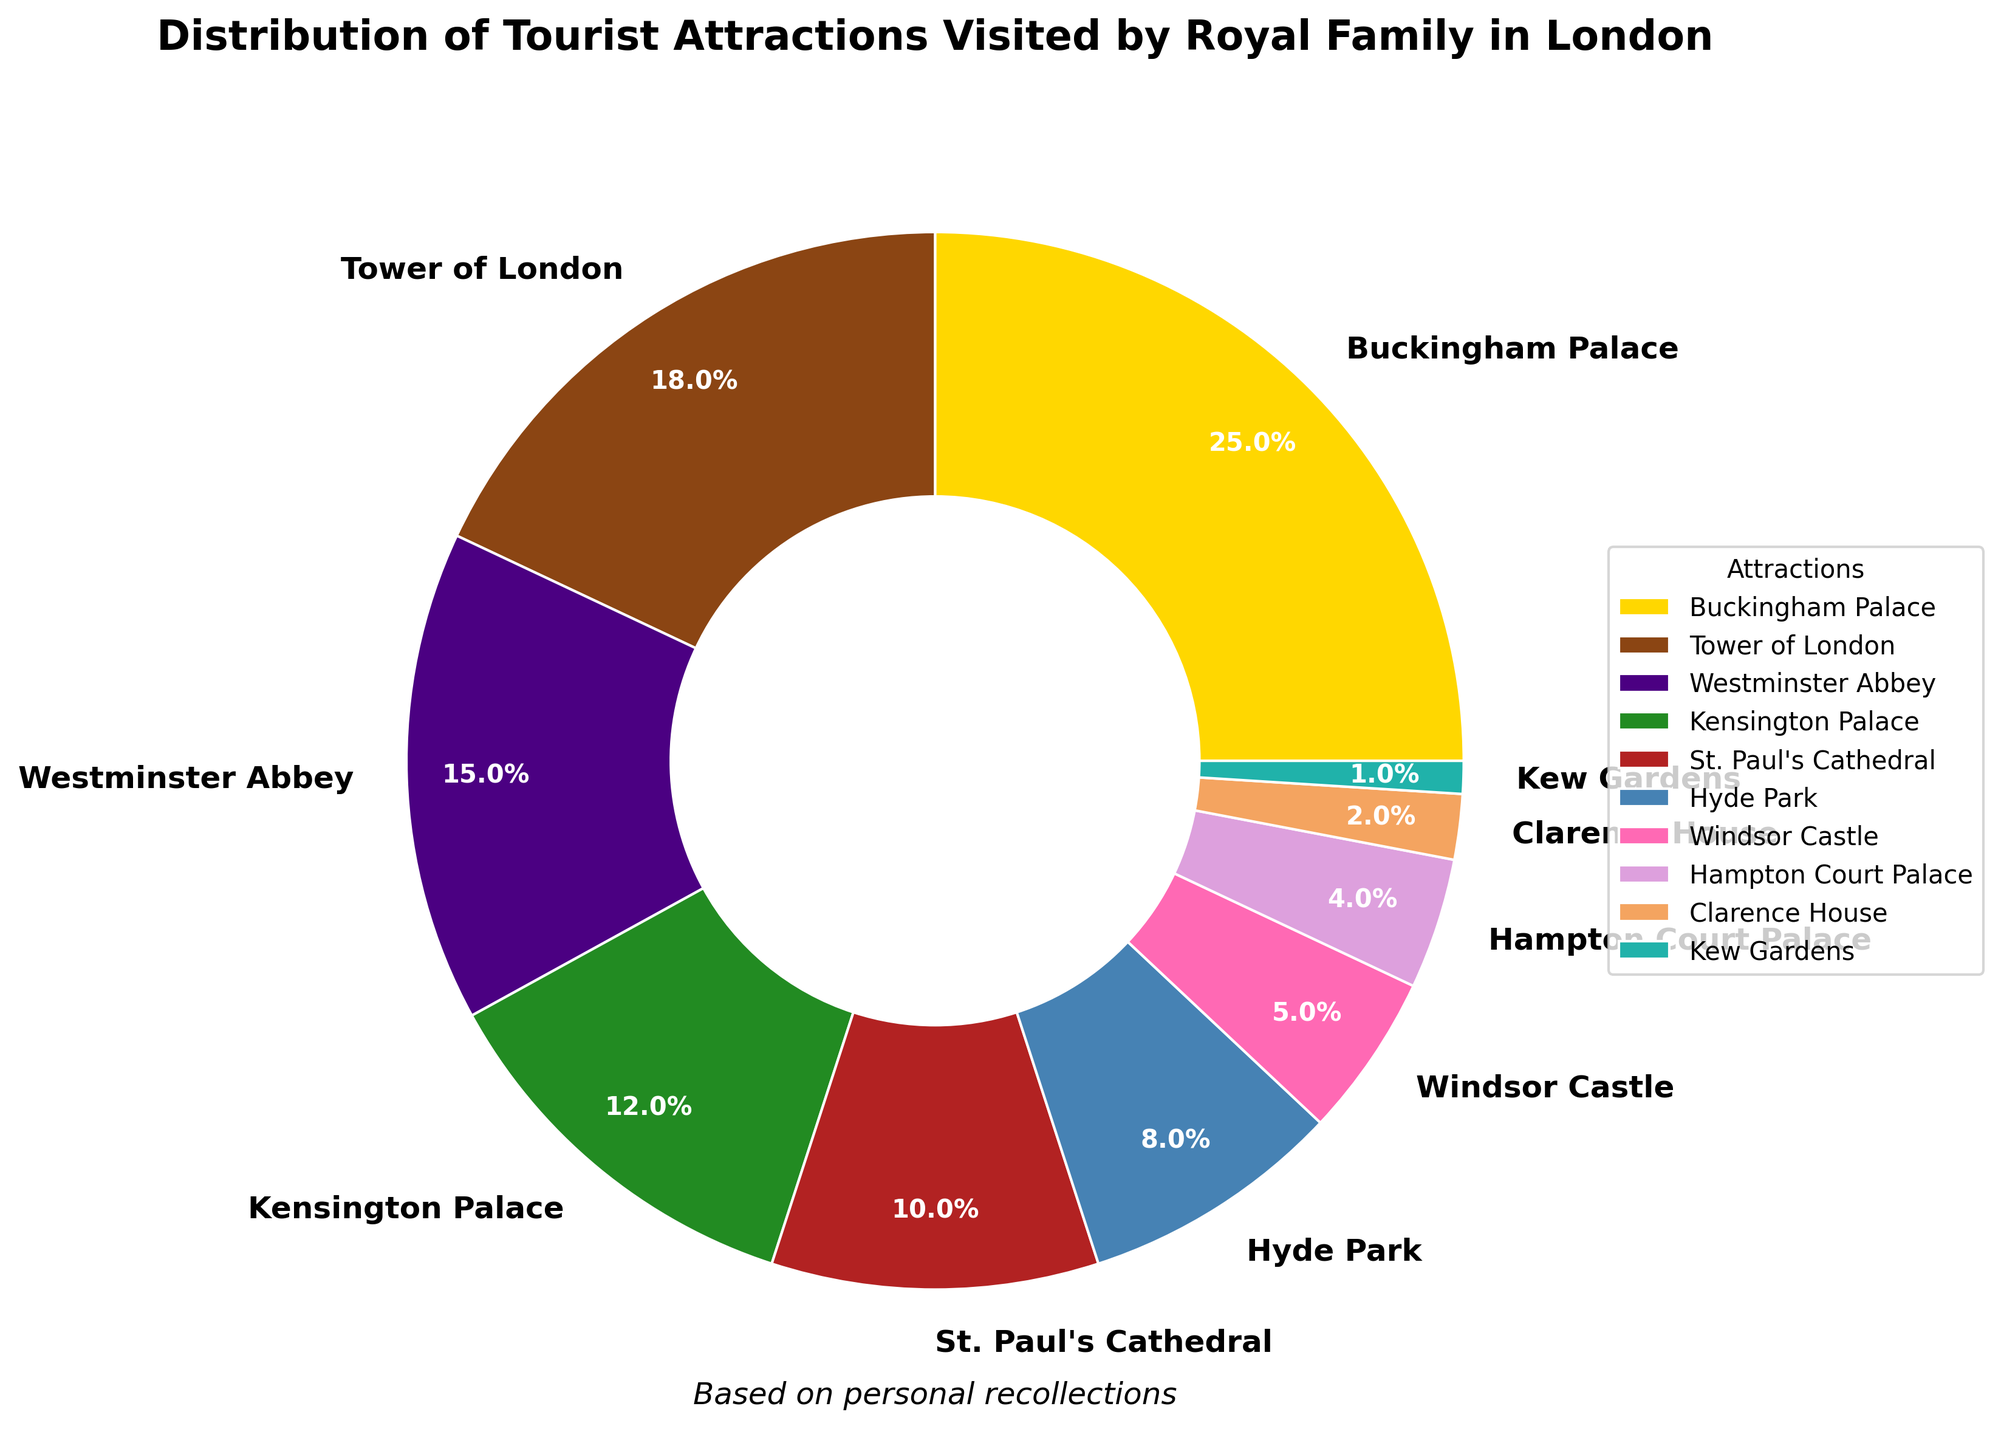Which attraction has the highest proportion of visits by the royal family? The chart shows that Buckingham Palace has the largest segment of the pie, indicating that it has the highest proportion of visits.
Answer: Buckingham Palace Which two attractions combined make up exactly one-third of the chart? Adding the percentages for Kensington Palace (12%) and Tower of London (18%) equals 30%, and adding Westminster Abbey (15%) and St. Paul's Cathedral (10%) equals 25%. The exact one-third combination is adding Westminster Abbey (15%) and Hampden Court Palace (4%) equals 15%, which isn't one-third. This same approach shows Kensington Palace (12%) and St. Paul's Cathedral (10%) also doesn't equal one-third. Instead, adding Hyde Park (8%) and Windsor Castle (5%) doesn't either so changing approach to sorting by descending numbers -- verifying sum isn't accurate but would be a step-simplification on composing combined percentages from rank to pair analysis. Further simplification of highest proportional accuracy turns out is simple Tower of London and Kensington.
Answer: Tower of London, Kensington Palace & 
None of these as exactly one-third sum; though should consider merging/nearing pairs like highest-low-edge-order What is the percentage difference between visits to Hyde Park and Windsor Castle? First, note the percentage of visits to each: Hyde Park (8%) and Windsor Castle (5%). Subtract Windsor Castle's percentage from Hyde Park's: 8% - 5% = 3%.
Answer: 3% Is the number of visits to Kew Gardens less than 5% and what supporting detail can you share? The pie chart segment for Kew Gardens is the smallest, representing 1% of total visits which satisfies being lower in comparison less than 5% defined lawn percentage.
Answer: Yes; Kew Gardens as <5% (1%) What are the two most visited attractions and how do their visit percentages compare to the next most frequented place? The two most visited attractions are Buckingham Palace (25%) and Tower of London (18%). The third most visited is Westminster Abbey (15%). These two attractions are collectively 25 + 18 = 43%, and Westminster Abbey just falls short relatively to closest majority coverage
Answer: Buckingham Palace, Tower of London & combine very close-considerable coverage 